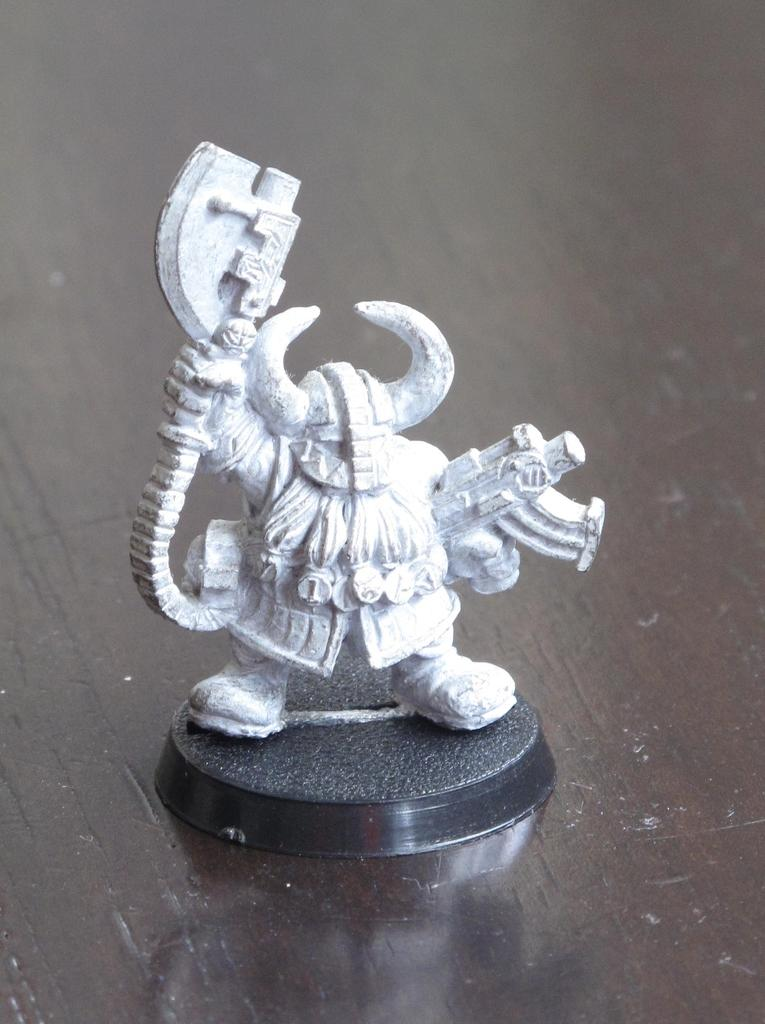What is the main subject of the image? There is a statue in the image. Can you describe the size of the statue? The statue is small in size. How does the statue appear in terms of its design or purpose? The statue resembles a toy. Is the statue capable of experiencing rain in the image? There is no indication of rain or any weather conditions in the image, and the statue is not a living being, so it cannot experience rain. 